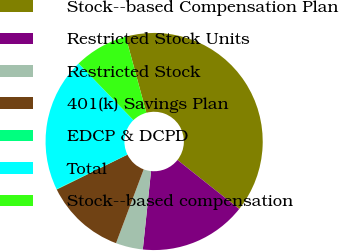Convert chart to OTSL. <chart><loc_0><loc_0><loc_500><loc_500><pie_chart><fcel>Stock-­based Compensation Plan<fcel>Restricted Stock Units<fcel>Restricted Stock<fcel>401(k) Savings Plan<fcel>EDCP & DCPD<fcel>Total<fcel>Stock-­based compensation<nl><fcel>39.89%<fcel>15.99%<fcel>4.04%<fcel>12.01%<fcel>0.06%<fcel>19.98%<fcel>8.03%<nl></chart> 